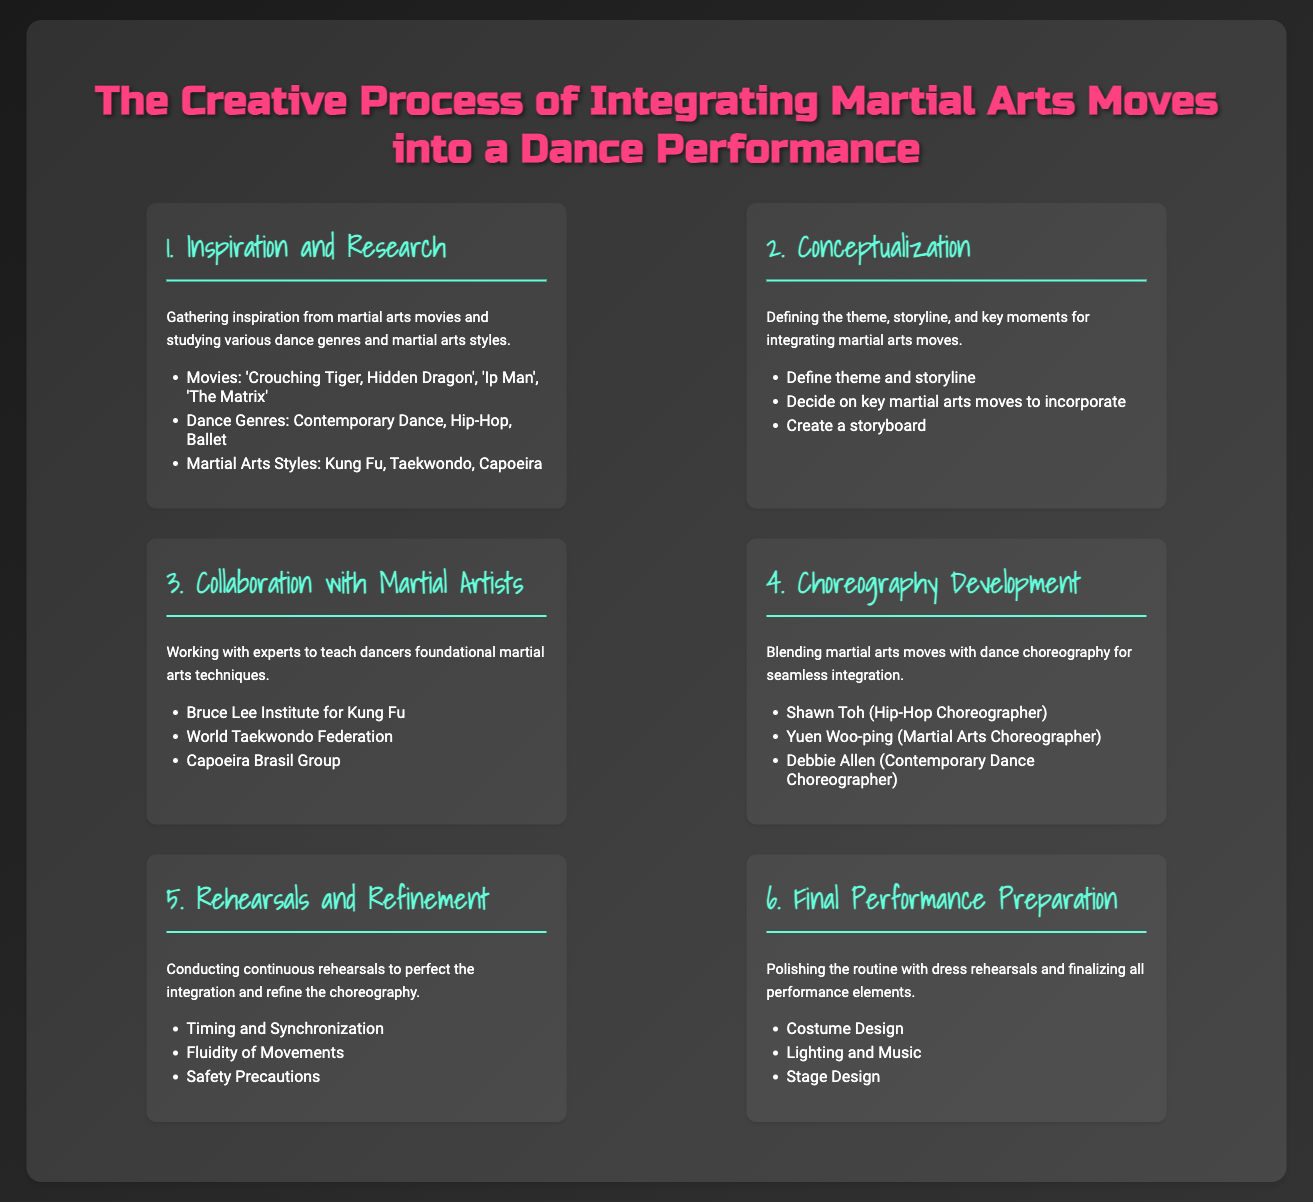What is the first step in the process? The first step in the process is titled 'Inspiration and Research', which involves gathering inspiration from martial arts movies and studying various dance genres and martial arts styles.
Answer: Inspiration and Research Name one martial arts style mentioned in the document. The document lists several martial arts styles, including Kung Fu, Taekwondo, and Capoeira.
Answer: Kung Fu How many main steps are there in the creative process? The creative process consists of a total of six main steps as outlined in the infographic.
Answer: Six Who is a choreographer associated with Hip-Hop? Shawn Toh is mentioned as a Hip-Hop choreographer in the choreography development step of the process.
Answer: Shawn Toh What is one of the elements finalized during the final performance preparation? The infographic lists several elements that are finalized, one of which is costume design.
Answer: Costume Design What is the primary goal of rehearsals and refinement? The primary goal of this step is to perfect the integration and refine the choreography through continuous rehearsals.
Answer: Perfect integration Which movie is mentioned as a source of inspiration? The document mentions several martial arts movies, one of which is 'Crouching Tiger, Hidden Dragon'.
Answer: 'Crouching Tiger, Hidden Dragon' What is created during the conceptualization step? In this step, a storyboard is created as part of defining the theme and storyline for the performance.
Answer: Storyboard Name a group mentioned for collaboration with martial artists. The document lists the Bruce Lee Institute for Kung Fu as one group involved in collaboration.
Answer: Bruce Lee Institute for Kung Fu 